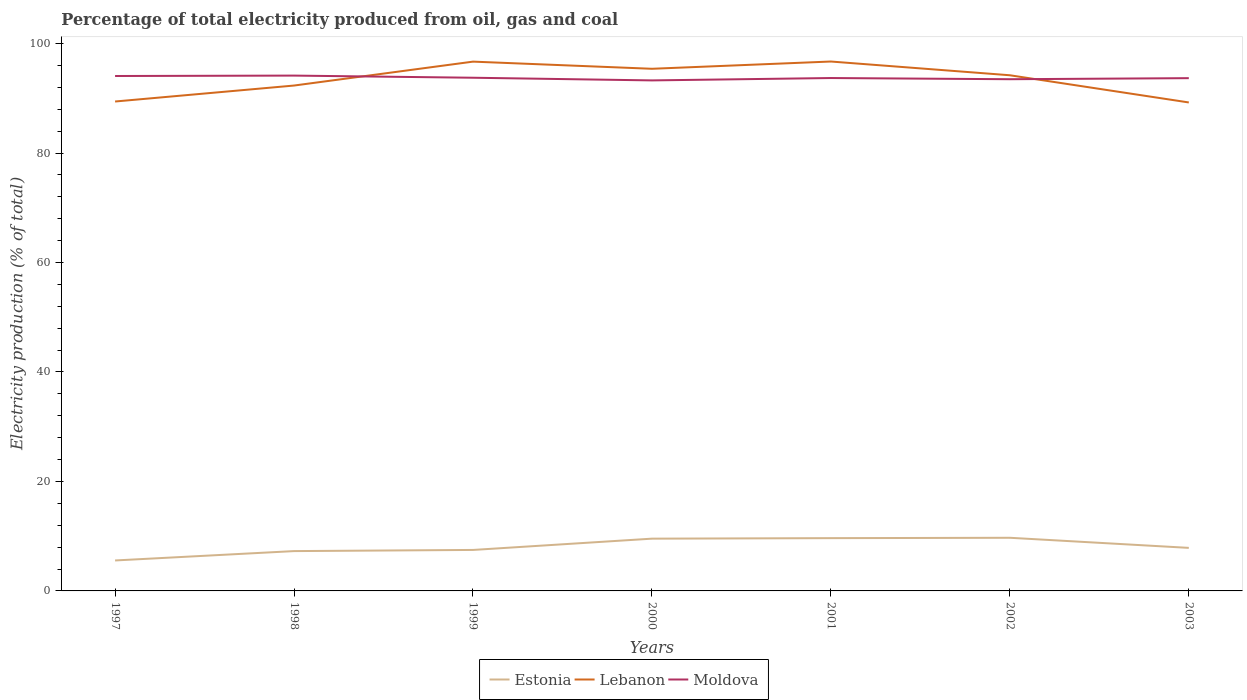Across all years, what is the maximum electricity production in in Lebanon?
Give a very brief answer. 89.25. In which year was the electricity production in in Estonia maximum?
Provide a short and direct response. 1997. What is the total electricity production in in Estonia in the graph?
Give a very brief answer. -0.38. What is the difference between the highest and the second highest electricity production in in Lebanon?
Ensure brevity in your answer.  7.48. What is the difference between the highest and the lowest electricity production in in Lebanon?
Provide a succinct answer. 4. Is the electricity production in in Moldova strictly greater than the electricity production in in Lebanon over the years?
Your response must be concise. No. How many lines are there?
Provide a short and direct response. 3. How many years are there in the graph?
Keep it short and to the point. 7. What is the difference between two consecutive major ticks on the Y-axis?
Make the answer very short. 20. Are the values on the major ticks of Y-axis written in scientific E-notation?
Your answer should be compact. No. Does the graph contain any zero values?
Keep it short and to the point. No. Does the graph contain grids?
Your answer should be compact. No. Where does the legend appear in the graph?
Ensure brevity in your answer.  Bottom center. How many legend labels are there?
Provide a short and direct response. 3. How are the legend labels stacked?
Your answer should be compact. Horizontal. What is the title of the graph?
Provide a short and direct response. Percentage of total electricity produced from oil, gas and coal. What is the label or title of the Y-axis?
Make the answer very short. Electricity production (% of total). What is the Electricity production (% of total) in Estonia in 1997?
Provide a short and direct response. 5.57. What is the Electricity production (% of total) of Lebanon in 1997?
Ensure brevity in your answer.  89.42. What is the Electricity production (% of total) of Moldova in 1997?
Ensure brevity in your answer.  94.08. What is the Electricity production (% of total) of Estonia in 1998?
Your answer should be compact. 7.28. What is the Electricity production (% of total) in Lebanon in 1998?
Provide a short and direct response. 92.34. What is the Electricity production (% of total) in Moldova in 1998?
Your answer should be very brief. 94.16. What is the Electricity production (% of total) of Estonia in 1999?
Offer a terse response. 7.49. What is the Electricity production (% of total) of Lebanon in 1999?
Provide a short and direct response. 96.71. What is the Electricity production (% of total) in Moldova in 1999?
Keep it short and to the point. 93.76. What is the Electricity production (% of total) in Estonia in 2000?
Offer a terse response. 9.55. What is the Electricity production (% of total) of Lebanon in 2000?
Ensure brevity in your answer.  95.4. What is the Electricity production (% of total) of Moldova in 2000?
Make the answer very short. 93.28. What is the Electricity production (% of total) in Estonia in 2001?
Offer a very short reply. 9.64. What is the Electricity production (% of total) in Lebanon in 2001?
Offer a terse response. 96.72. What is the Electricity production (% of total) of Moldova in 2001?
Your answer should be very brief. 93.71. What is the Electricity production (% of total) in Estonia in 2002?
Offer a very short reply. 9.71. What is the Electricity production (% of total) of Lebanon in 2002?
Offer a very short reply. 94.22. What is the Electricity production (% of total) in Moldova in 2002?
Provide a short and direct response. 93.49. What is the Electricity production (% of total) of Estonia in 2003?
Provide a succinct answer. 7.86. What is the Electricity production (% of total) of Lebanon in 2003?
Give a very brief answer. 89.25. What is the Electricity production (% of total) of Moldova in 2003?
Give a very brief answer. 93.69. Across all years, what is the maximum Electricity production (% of total) of Estonia?
Keep it short and to the point. 9.71. Across all years, what is the maximum Electricity production (% of total) in Lebanon?
Your answer should be compact. 96.72. Across all years, what is the maximum Electricity production (% of total) of Moldova?
Your answer should be very brief. 94.16. Across all years, what is the minimum Electricity production (% of total) of Estonia?
Give a very brief answer. 5.57. Across all years, what is the minimum Electricity production (% of total) of Lebanon?
Your response must be concise. 89.25. Across all years, what is the minimum Electricity production (% of total) in Moldova?
Your response must be concise. 93.28. What is the total Electricity production (% of total) in Estonia in the graph?
Give a very brief answer. 57.1. What is the total Electricity production (% of total) in Lebanon in the graph?
Make the answer very short. 654.05. What is the total Electricity production (% of total) in Moldova in the graph?
Provide a succinct answer. 656.16. What is the difference between the Electricity production (% of total) of Estonia in 1997 and that in 1998?
Your answer should be compact. -1.71. What is the difference between the Electricity production (% of total) of Lebanon in 1997 and that in 1998?
Your response must be concise. -2.92. What is the difference between the Electricity production (% of total) of Moldova in 1997 and that in 1998?
Ensure brevity in your answer.  -0.08. What is the difference between the Electricity production (% of total) in Estonia in 1997 and that in 1999?
Offer a very short reply. -1.92. What is the difference between the Electricity production (% of total) in Lebanon in 1997 and that in 1999?
Ensure brevity in your answer.  -7.29. What is the difference between the Electricity production (% of total) of Moldova in 1997 and that in 1999?
Keep it short and to the point. 0.32. What is the difference between the Electricity production (% of total) in Estonia in 1997 and that in 2000?
Your answer should be compact. -3.98. What is the difference between the Electricity production (% of total) in Lebanon in 1997 and that in 2000?
Keep it short and to the point. -5.98. What is the difference between the Electricity production (% of total) of Moldova in 1997 and that in 2000?
Make the answer very short. 0.8. What is the difference between the Electricity production (% of total) of Estonia in 1997 and that in 2001?
Your answer should be compact. -4.08. What is the difference between the Electricity production (% of total) of Lebanon in 1997 and that in 2001?
Provide a short and direct response. -7.31. What is the difference between the Electricity production (% of total) in Moldova in 1997 and that in 2001?
Give a very brief answer. 0.37. What is the difference between the Electricity production (% of total) of Estonia in 1997 and that in 2002?
Ensure brevity in your answer.  -4.15. What is the difference between the Electricity production (% of total) of Lebanon in 1997 and that in 2002?
Ensure brevity in your answer.  -4.8. What is the difference between the Electricity production (% of total) of Moldova in 1997 and that in 2002?
Provide a short and direct response. 0.59. What is the difference between the Electricity production (% of total) in Estonia in 1997 and that in 2003?
Offer a very short reply. -2.3. What is the difference between the Electricity production (% of total) of Lebanon in 1997 and that in 2003?
Your answer should be compact. 0.17. What is the difference between the Electricity production (% of total) in Moldova in 1997 and that in 2003?
Offer a terse response. 0.39. What is the difference between the Electricity production (% of total) of Estonia in 1998 and that in 1999?
Ensure brevity in your answer.  -0.21. What is the difference between the Electricity production (% of total) in Lebanon in 1998 and that in 1999?
Provide a short and direct response. -4.37. What is the difference between the Electricity production (% of total) of Moldova in 1998 and that in 1999?
Provide a succinct answer. 0.39. What is the difference between the Electricity production (% of total) in Estonia in 1998 and that in 2000?
Offer a very short reply. -2.27. What is the difference between the Electricity production (% of total) in Lebanon in 1998 and that in 2000?
Provide a short and direct response. -3.06. What is the difference between the Electricity production (% of total) in Estonia in 1998 and that in 2001?
Provide a short and direct response. -2.37. What is the difference between the Electricity production (% of total) of Lebanon in 1998 and that in 2001?
Offer a terse response. -4.39. What is the difference between the Electricity production (% of total) of Moldova in 1998 and that in 2001?
Keep it short and to the point. 0.45. What is the difference between the Electricity production (% of total) of Estonia in 1998 and that in 2002?
Make the answer very short. -2.43. What is the difference between the Electricity production (% of total) of Lebanon in 1998 and that in 2002?
Ensure brevity in your answer.  -1.88. What is the difference between the Electricity production (% of total) of Moldova in 1998 and that in 2002?
Keep it short and to the point. 0.66. What is the difference between the Electricity production (% of total) of Estonia in 1998 and that in 2003?
Keep it short and to the point. -0.59. What is the difference between the Electricity production (% of total) in Lebanon in 1998 and that in 2003?
Ensure brevity in your answer.  3.09. What is the difference between the Electricity production (% of total) of Moldova in 1998 and that in 2003?
Offer a very short reply. 0.47. What is the difference between the Electricity production (% of total) of Estonia in 1999 and that in 2000?
Ensure brevity in your answer.  -2.06. What is the difference between the Electricity production (% of total) in Lebanon in 1999 and that in 2000?
Ensure brevity in your answer.  1.31. What is the difference between the Electricity production (% of total) of Moldova in 1999 and that in 2000?
Offer a terse response. 0.49. What is the difference between the Electricity production (% of total) in Estonia in 1999 and that in 2001?
Provide a short and direct response. -2.16. What is the difference between the Electricity production (% of total) in Lebanon in 1999 and that in 2001?
Keep it short and to the point. -0.02. What is the difference between the Electricity production (% of total) in Moldova in 1999 and that in 2001?
Your response must be concise. 0.06. What is the difference between the Electricity production (% of total) in Estonia in 1999 and that in 2002?
Offer a terse response. -2.22. What is the difference between the Electricity production (% of total) in Lebanon in 1999 and that in 2002?
Offer a very short reply. 2.49. What is the difference between the Electricity production (% of total) of Moldova in 1999 and that in 2002?
Ensure brevity in your answer.  0.27. What is the difference between the Electricity production (% of total) in Estonia in 1999 and that in 2003?
Give a very brief answer. -0.38. What is the difference between the Electricity production (% of total) in Lebanon in 1999 and that in 2003?
Your answer should be very brief. 7.46. What is the difference between the Electricity production (% of total) of Moldova in 1999 and that in 2003?
Provide a succinct answer. 0.08. What is the difference between the Electricity production (% of total) of Estonia in 2000 and that in 2001?
Provide a succinct answer. -0.09. What is the difference between the Electricity production (% of total) of Lebanon in 2000 and that in 2001?
Your response must be concise. -1.33. What is the difference between the Electricity production (% of total) in Moldova in 2000 and that in 2001?
Your answer should be compact. -0.43. What is the difference between the Electricity production (% of total) in Estonia in 2000 and that in 2002?
Provide a succinct answer. -0.16. What is the difference between the Electricity production (% of total) of Lebanon in 2000 and that in 2002?
Provide a short and direct response. 1.18. What is the difference between the Electricity production (% of total) in Moldova in 2000 and that in 2002?
Ensure brevity in your answer.  -0.22. What is the difference between the Electricity production (% of total) in Estonia in 2000 and that in 2003?
Ensure brevity in your answer.  1.69. What is the difference between the Electricity production (% of total) in Lebanon in 2000 and that in 2003?
Give a very brief answer. 6.15. What is the difference between the Electricity production (% of total) in Moldova in 2000 and that in 2003?
Provide a short and direct response. -0.41. What is the difference between the Electricity production (% of total) in Estonia in 2001 and that in 2002?
Provide a succinct answer. -0.07. What is the difference between the Electricity production (% of total) of Lebanon in 2001 and that in 2002?
Offer a very short reply. 2.51. What is the difference between the Electricity production (% of total) of Moldova in 2001 and that in 2002?
Your answer should be very brief. 0.22. What is the difference between the Electricity production (% of total) in Estonia in 2001 and that in 2003?
Ensure brevity in your answer.  1.78. What is the difference between the Electricity production (% of total) of Lebanon in 2001 and that in 2003?
Provide a short and direct response. 7.48. What is the difference between the Electricity production (% of total) of Moldova in 2001 and that in 2003?
Your answer should be compact. 0.02. What is the difference between the Electricity production (% of total) of Estonia in 2002 and that in 2003?
Give a very brief answer. 1.85. What is the difference between the Electricity production (% of total) of Lebanon in 2002 and that in 2003?
Provide a succinct answer. 4.97. What is the difference between the Electricity production (% of total) of Moldova in 2002 and that in 2003?
Provide a short and direct response. -0.19. What is the difference between the Electricity production (% of total) in Estonia in 1997 and the Electricity production (% of total) in Lebanon in 1998?
Ensure brevity in your answer.  -86.77. What is the difference between the Electricity production (% of total) of Estonia in 1997 and the Electricity production (% of total) of Moldova in 1998?
Your answer should be very brief. -88.59. What is the difference between the Electricity production (% of total) of Lebanon in 1997 and the Electricity production (% of total) of Moldova in 1998?
Provide a short and direct response. -4.74. What is the difference between the Electricity production (% of total) in Estonia in 1997 and the Electricity production (% of total) in Lebanon in 1999?
Provide a succinct answer. -91.14. What is the difference between the Electricity production (% of total) in Estonia in 1997 and the Electricity production (% of total) in Moldova in 1999?
Your response must be concise. -88.2. What is the difference between the Electricity production (% of total) of Lebanon in 1997 and the Electricity production (% of total) of Moldova in 1999?
Offer a very short reply. -4.34. What is the difference between the Electricity production (% of total) in Estonia in 1997 and the Electricity production (% of total) in Lebanon in 2000?
Your answer should be very brief. -89.83. What is the difference between the Electricity production (% of total) in Estonia in 1997 and the Electricity production (% of total) in Moldova in 2000?
Your answer should be very brief. -87.71. What is the difference between the Electricity production (% of total) in Lebanon in 1997 and the Electricity production (% of total) in Moldova in 2000?
Keep it short and to the point. -3.86. What is the difference between the Electricity production (% of total) in Estonia in 1997 and the Electricity production (% of total) in Lebanon in 2001?
Provide a succinct answer. -91.16. What is the difference between the Electricity production (% of total) in Estonia in 1997 and the Electricity production (% of total) in Moldova in 2001?
Your answer should be very brief. -88.14. What is the difference between the Electricity production (% of total) of Lebanon in 1997 and the Electricity production (% of total) of Moldova in 2001?
Keep it short and to the point. -4.29. What is the difference between the Electricity production (% of total) in Estonia in 1997 and the Electricity production (% of total) in Lebanon in 2002?
Your answer should be compact. -88.65. What is the difference between the Electricity production (% of total) in Estonia in 1997 and the Electricity production (% of total) in Moldova in 2002?
Ensure brevity in your answer.  -87.93. What is the difference between the Electricity production (% of total) in Lebanon in 1997 and the Electricity production (% of total) in Moldova in 2002?
Offer a very short reply. -4.07. What is the difference between the Electricity production (% of total) of Estonia in 1997 and the Electricity production (% of total) of Lebanon in 2003?
Your response must be concise. -83.68. What is the difference between the Electricity production (% of total) in Estonia in 1997 and the Electricity production (% of total) in Moldova in 2003?
Your answer should be compact. -88.12. What is the difference between the Electricity production (% of total) in Lebanon in 1997 and the Electricity production (% of total) in Moldova in 2003?
Give a very brief answer. -4.27. What is the difference between the Electricity production (% of total) of Estonia in 1998 and the Electricity production (% of total) of Lebanon in 1999?
Ensure brevity in your answer.  -89.43. What is the difference between the Electricity production (% of total) in Estonia in 1998 and the Electricity production (% of total) in Moldova in 1999?
Keep it short and to the point. -86.49. What is the difference between the Electricity production (% of total) of Lebanon in 1998 and the Electricity production (% of total) of Moldova in 1999?
Keep it short and to the point. -1.43. What is the difference between the Electricity production (% of total) in Estonia in 1998 and the Electricity production (% of total) in Lebanon in 2000?
Provide a succinct answer. -88.12. What is the difference between the Electricity production (% of total) in Estonia in 1998 and the Electricity production (% of total) in Moldova in 2000?
Your answer should be compact. -86. What is the difference between the Electricity production (% of total) in Lebanon in 1998 and the Electricity production (% of total) in Moldova in 2000?
Offer a very short reply. -0.94. What is the difference between the Electricity production (% of total) in Estonia in 1998 and the Electricity production (% of total) in Lebanon in 2001?
Offer a very short reply. -89.45. What is the difference between the Electricity production (% of total) in Estonia in 1998 and the Electricity production (% of total) in Moldova in 2001?
Your answer should be very brief. -86.43. What is the difference between the Electricity production (% of total) of Lebanon in 1998 and the Electricity production (% of total) of Moldova in 2001?
Provide a succinct answer. -1.37. What is the difference between the Electricity production (% of total) of Estonia in 1998 and the Electricity production (% of total) of Lebanon in 2002?
Provide a succinct answer. -86.94. What is the difference between the Electricity production (% of total) in Estonia in 1998 and the Electricity production (% of total) in Moldova in 2002?
Provide a short and direct response. -86.22. What is the difference between the Electricity production (% of total) in Lebanon in 1998 and the Electricity production (% of total) in Moldova in 2002?
Provide a short and direct response. -1.16. What is the difference between the Electricity production (% of total) of Estonia in 1998 and the Electricity production (% of total) of Lebanon in 2003?
Make the answer very short. -81.97. What is the difference between the Electricity production (% of total) in Estonia in 1998 and the Electricity production (% of total) in Moldova in 2003?
Provide a short and direct response. -86.41. What is the difference between the Electricity production (% of total) in Lebanon in 1998 and the Electricity production (% of total) in Moldova in 2003?
Provide a short and direct response. -1.35. What is the difference between the Electricity production (% of total) in Estonia in 1999 and the Electricity production (% of total) in Lebanon in 2000?
Provide a short and direct response. -87.91. What is the difference between the Electricity production (% of total) of Estonia in 1999 and the Electricity production (% of total) of Moldova in 2000?
Keep it short and to the point. -85.79. What is the difference between the Electricity production (% of total) in Lebanon in 1999 and the Electricity production (% of total) in Moldova in 2000?
Give a very brief answer. 3.43. What is the difference between the Electricity production (% of total) in Estonia in 1999 and the Electricity production (% of total) in Lebanon in 2001?
Offer a terse response. -89.24. What is the difference between the Electricity production (% of total) of Estonia in 1999 and the Electricity production (% of total) of Moldova in 2001?
Make the answer very short. -86.22. What is the difference between the Electricity production (% of total) in Lebanon in 1999 and the Electricity production (% of total) in Moldova in 2001?
Make the answer very short. 3. What is the difference between the Electricity production (% of total) of Estonia in 1999 and the Electricity production (% of total) of Lebanon in 2002?
Your answer should be compact. -86.73. What is the difference between the Electricity production (% of total) of Estonia in 1999 and the Electricity production (% of total) of Moldova in 2002?
Your answer should be very brief. -86.01. What is the difference between the Electricity production (% of total) of Lebanon in 1999 and the Electricity production (% of total) of Moldova in 2002?
Provide a short and direct response. 3.21. What is the difference between the Electricity production (% of total) of Estonia in 1999 and the Electricity production (% of total) of Lebanon in 2003?
Your response must be concise. -81.76. What is the difference between the Electricity production (% of total) in Estonia in 1999 and the Electricity production (% of total) in Moldova in 2003?
Make the answer very short. -86.2. What is the difference between the Electricity production (% of total) in Lebanon in 1999 and the Electricity production (% of total) in Moldova in 2003?
Your response must be concise. 3.02. What is the difference between the Electricity production (% of total) of Estonia in 2000 and the Electricity production (% of total) of Lebanon in 2001?
Provide a short and direct response. -87.17. What is the difference between the Electricity production (% of total) of Estonia in 2000 and the Electricity production (% of total) of Moldova in 2001?
Make the answer very short. -84.16. What is the difference between the Electricity production (% of total) in Lebanon in 2000 and the Electricity production (% of total) in Moldova in 2001?
Ensure brevity in your answer.  1.69. What is the difference between the Electricity production (% of total) in Estonia in 2000 and the Electricity production (% of total) in Lebanon in 2002?
Your response must be concise. -84.67. What is the difference between the Electricity production (% of total) of Estonia in 2000 and the Electricity production (% of total) of Moldova in 2002?
Your response must be concise. -83.94. What is the difference between the Electricity production (% of total) in Lebanon in 2000 and the Electricity production (% of total) in Moldova in 2002?
Provide a short and direct response. 1.91. What is the difference between the Electricity production (% of total) in Estonia in 2000 and the Electricity production (% of total) in Lebanon in 2003?
Offer a terse response. -79.7. What is the difference between the Electricity production (% of total) of Estonia in 2000 and the Electricity production (% of total) of Moldova in 2003?
Keep it short and to the point. -84.14. What is the difference between the Electricity production (% of total) of Lebanon in 2000 and the Electricity production (% of total) of Moldova in 2003?
Your response must be concise. 1.71. What is the difference between the Electricity production (% of total) of Estonia in 2001 and the Electricity production (% of total) of Lebanon in 2002?
Give a very brief answer. -84.57. What is the difference between the Electricity production (% of total) in Estonia in 2001 and the Electricity production (% of total) in Moldova in 2002?
Offer a very short reply. -83.85. What is the difference between the Electricity production (% of total) in Lebanon in 2001 and the Electricity production (% of total) in Moldova in 2002?
Offer a terse response. 3.23. What is the difference between the Electricity production (% of total) in Estonia in 2001 and the Electricity production (% of total) in Lebanon in 2003?
Offer a very short reply. -79.6. What is the difference between the Electricity production (% of total) in Estonia in 2001 and the Electricity production (% of total) in Moldova in 2003?
Your response must be concise. -84.04. What is the difference between the Electricity production (% of total) in Lebanon in 2001 and the Electricity production (% of total) in Moldova in 2003?
Provide a succinct answer. 3.04. What is the difference between the Electricity production (% of total) in Estonia in 2002 and the Electricity production (% of total) in Lebanon in 2003?
Your answer should be very brief. -79.54. What is the difference between the Electricity production (% of total) of Estonia in 2002 and the Electricity production (% of total) of Moldova in 2003?
Ensure brevity in your answer.  -83.98. What is the difference between the Electricity production (% of total) of Lebanon in 2002 and the Electricity production (% of total) of Moldova in 2003?
Your answer should be compact. 0.53. What is the average Electricity production (% of total) of Estonia per year?
Your answer should be very brief. 8.16. What is the average Electricity production (% of total) in Lebanon per year?
Give a very brief answer. 93.44. What is the average Electricity production (% of total) of Moldova per year?
Provide a succinct answer. 93.74. In the year 1997, what is the difference between the Electricity production (% of total) of Estonia and Electricity production (% of total) of Lebanon?
Your response must be concise. -83.85. In the year 1997, what is the difference between the Electricity production (% of total) of Estonia and Electricity production (% of total) of Moldova?
Provide a short and direct response. -88.51. In the year 1997, what is the difference between the Electricity production (% of total) of Lebanon and Electricity production (% of total) of Moldova?
Your answer should be very brief. -4.66. In the year 1998, what is the difference between the Electricity production (% of total) of Estonia and Electricity production (% of total) of Lebanon?
Your answer should be very brief. -85.06. In the year 1998, what is the difference between the Electricity production (% of total) of Estonia and Electricity production (% of total) of Moldova?
Provide a succinct answer. -86.88. In the year 1998, what is the difference between the Electricity production (% of total) of Lebanon and Electricity production (% of total) of Moldova?
Your answer should be very brief. -1.82. In the year 1999, what is the difference between the Electricity production (% of total) in Estonia and Electricity production (% of total) in Lebanon?
Make the answer very short. -89.22. In the year 1999, what is the difference between the Electricity production (% of total) in Estonia and Electricity production (% of total) in Moldova?
Your answer should be compact. -86.28. In the year 1999, what is the difference between the Electricity production (% of total) of Lebanon and Electricity production (% of total) of Moldova?
Keep it short and to the point. 2.94. In the year 2000, what is the difference between the Electricity production (% of total) of Estonia and Electricity production (% of total) of Lebanon?
Offer a terse response. -85.85. In the year 2000, what is the difference between the Electricity production (% of total) in Estonia and Electricity production (% of total) in Moldova?
Ensure brevity in your answer.  -83.72. In the year 2000, what is the difference between the Electricity production (% of total) of Lebanon and Electricity production (% of total) of Moldova?
Make the answer very short. 2.12. In the year 2001, what is the difference between the Electricity production (% of total) in Estonia and Electricity production (% of total) in Lebanon?
Your answer should be very brief. -87.08. In the year 2001, what is the difference between the Electricity production (% of total) of Estonia and Electricity production (% of total) of Moldova?
Offer a terse response. -84.06. In the year 2001, what is the difference between the Electricity production (% of total) in Lebanon and Electricity production (% of total) in Moldova?
Ensure brevity in your answer.  3.02. In the year 2002, what is the difference between the Electricity production (% of total) of Estonia and Electricity production (% of total) of Lebanon?
Make the answer very short. -84.51. In the year 2002, what is the difference between the Electricity production (% of total) in Estonia and Electricity production (% of total) in Moldova?
Your answer should be compact. -83.78. In the year 2002, what is the difference between the Electricity production (% of total) of Lebanon and Electricity production (% of total) of Moldova?
Your response must be concise. 0.72. In the year 2003, what is the difference between the Electricity production (% of total) in Estonia and Electricity production (% of total) in Lebanon?
Keep it short and to the point. -81.38. In the year 2003, what is the difference between the Electricity production (% of total) in Estonia and Electricity production (% of total) in Moldova?
Keep it short and to the point. -85.82. In the year 2003, what is the difference between the Electricity production (% of total) in Lebanon and Electricity production (% of total) in Moldova?
Offer a terse response. -4.44. What is the ratio of the Electricity production (% of total) in Estonia in 1997 to that in 1998?
Ensure brevity in your answer.  0.76. What is the ratio of the Electricity production (% of total) in Lebanon in 1997 to that in 1998?
Offer a very short reply. 0.97. What is the ratio of the Electricity production (% of total) in Moldova in 1997 to that in 1998?
Provide a succinct answer. 1. What is the ratio of the Electricity production (% of total) of Estonia in 1997 to that in 1999?
Make the answer very short. 0.74. What is the ratio of the Electricity production (% of total) of Lebanon in 1997 to that in 1999?
Offer a very short reply. 0.92. What is the ratio of the Electricity production (% of total) of Estonia in 1997 to that in 2000?
Ensure brevity in your answer.  0.58. What is the ratio of the Electricity production (% of total) in Lebanon in 1997 to that in 2000?
Your response must be concise. 0.94. What is the ratio of the Electricity production (% of total) of Moldova in 1997 to that in 2000?
Give a very brief answer. 1.01. What is the ratio of the Electricity production (% of total) of Estonia in 1997 to that in 2001?
Your answer should be very brief. 0.58. What is the ratio of the Electricity production (% of total) in Lebanon in 1997 to that in 2001?
Provide a short and direct response. 0.92. What is the ratio of the Electricity production (% of total) in Moldova in 1997 to that in 2001?
Give a very brief answer. 1. What is the ratio of the Electricity production (% of total) of Estonia in 1997 to that in 2002?
Provide a short and direct response. 0.57. What is the ratio of the Electricity production (% of total) of Lebanon in 1997 to that in 2002?
Ensure brevity in your answer.  0.95. What is the ratio of the Electricity production (% of total) of Estonia in 1997 to that in 2003?
Ensure brevity in your answer.  0.71. What is the ratio of the Electricity production (% of total) in Moldova in 1997 to that in 2003?
Your answer should be very brief. 1. What is the ratio of the Electricity production (% of total) of Estonia in 1998 to that in 1999?
Provide a short and direct response. 0.97. What is the ratio of the Electricity production (% of total) in Lebanon in 1998 to that in 1999?
Give a very brief answer. 0.95. What is the ratio of the Electricity production (% of total) of Moldova in 1998 to that in 1999?
Offer a very short reply. 1. What is the ratio of the Electricity production (% of total) in Estonia in 1998 to that in 2000?
Keep it short and to the point. 0.76. What is the ratio of the Electricity production (% of total) of Lebanon in 1998 to that in 2000?
Offer a terse response. 0.97. What is the ratio of the Electricity production (% of total) in Moldova in 1998 to that in 2000?
Provide a short and direct response. 1.01. What is the ratio of the Electricity production (% of total) in Estonia in 1998 to that in 2001?
Give a very brief answer. 0.75. What is the ratio of the Electricity production (% of total) of Lebanon in 1998 to that in 2001?
Ensure brevity in your answer.  0.95. What is the ratio of the Electricity production (% of total) in Moldova in 1998 to that in 2001?
Keep it short and to the point. 1. What is the ratio of the Electricity production (% of total) of Estonia in 1998 to that in 2002?
Your answer should be compact. 0.75. What is the ratio of the Electricity production (% of total) in Lebanon in 1998 to that in 2002?
Your answer should be very brief. 0.98. What is the ratio of the Electricity production (% of total) of Moldova in 1998 to that in 2002?
Your answer should be very brief. 1.01. What is the ratio of the Electricity production (% of total) in Estonia in 1998 to that in 2003?
Keep it short and to the point. 0.93. What is the ratio of the Electricity production (% of total) in Lebanon in 1998 to that in 2003?
Provide a short and direct response. 1.03. What is the ratio of the Electricity production (% of total) of Moldova in 1998 to that in 2003?
Provide a short and direct response. 1. What is the ratio of the Electricity production (% of total) of Estonia in 1999 to that in 2000?
Offer a very short reply. 0.78. What is the ratio of the Electricity production (% of total) of Lebanon in 1999 to that in 2000?
Ensure brevity in your answer.  1.01. What is the ratio of the Electricity production (% of total) of Moldova in 1999 to that in 2000?
Your response must be concise. 1.01. What is the ratio of the Electricity production (% of total) of Estonia in 1999 to that in 2001?
Your answer should be very brief. 0.78. What is the ratio of the Electricity production (% of total) of Moldova in 1999 to that in 2001?
Offer a terse response. 1. What is the ratio of the Electricity production (% of total) of Estonia in 1999 to that in 2002?
Your response must be concise. 0.77. What is the ratio of the Electricity production (% of total) of Lebanon in 1999 to that in 2002?
Offer a terse response. 1.03. What is the ratio of the Electricity production (% of total) of Moldova in 1999 to that in 2002?
Your response must be concise. 1. What is the ratio of the Electricity production (% of total) of Estonia in 1999 to that in 2003?
Keep it short and to the point. 0.95. What is the ratio of the Electricity production (% of total) in Lebanon in 1999 to that in 2003?
Your answer should be very brief. 1.08. What is the ratio of the Electricity production (% of total) of Moldova in 1999 to that in 2003?
Your answer should be compact. 1. What is the ratio of the Electricity production (% of total) of Estonia in 2000 to that in 2001?
Give a very brief answer. 0.99. What is the ratio of the Electricity production (% of total) of Lebanon in 2000 to that in 2001?
Your answer should be very brief. 0.99. What is the ratio of the Electricity production (% of total) of Estonia in 2000 to that in 2002?
Your answer should be very brief. 0.98. What is the ratio of the Electricity production (% of total) of Lebanon in 2000 to that in 2002?
Make the answer very short. 1.01. What is the ratio of the Electricity production (% of total) in Estonia in 2000 to that in 2003?
Your answer should be compact. 1.21. What is the ratio of the Electricity production (% of total) in Lebanon in 2000 to that in 2003?
Your answer should be very brief. 1.07. What is the ratio of the Electricity production (% of total) in Estonia in 2001 to that in 2002?
Provide a succinct answer. 0.99. What is the ratio of the Electricity production (% of total) in Lebanon in 2001 to that in 2002?
Provide a succinct answer. 1.03. What is the ratio of the Electricity production (% of total) in Moldova in 2001 to that in 2002?
Your response must be concise. 1. What is the ratio of the Electricity production (% of total) in Estonia in 2001 to that in 2003?
Offer a terse response. 1.23. What is the ratio of the Electricity production (% of total) of Lebanon in 2001 to that in 2003?
Your response must be concise. 1.08. What is the ratio of the Electricity production (% of total) of Moldova in 2001 to that in 2003?
Ensure brevity in your answer.  1. What is the ratio of the Electricity production (% of total) in Estonia in 2002 to that in 2003?
Give a very brief answer. 1.23. What is the ratio of the Electricity production (% of total) of Lebanon in 2002 to that in 2003?
Offer a terse response. 1.06. What is the difference between the highest and the second highest Electricity production (% of total) of Estonia?
Give a very brief answer. 0.07. What is the difference between the highest and the second highest Electricity production (% of total) in Lebanon?
Offer a very short reply. 0.02. What is the difference between the highest and the second highest Electricity production (% of total) of Moldova?
Your answer should be compact. 0.08. What is the difference between the highest and the lowest Electricity production (% of total) in Estonia?
Provide a succinct answer. 4.15. What is the difference between the highest and the lowest Electricity production (% of total) in Lebanon?
Make the answer very short. 7.48. What is the difference between the highest and the lowest Electricity production (% of total) in Moldova?
Provide a short and direct response. 0.88. 